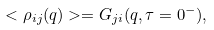Convert formula to latex. <formula><loc_0><loc_0><loc_500><loc_500>< \rho _ { i j } ( { q } ) > = G _ { j i } ( { q } , \tau = 0 ^ { - } ) ,</formula> 